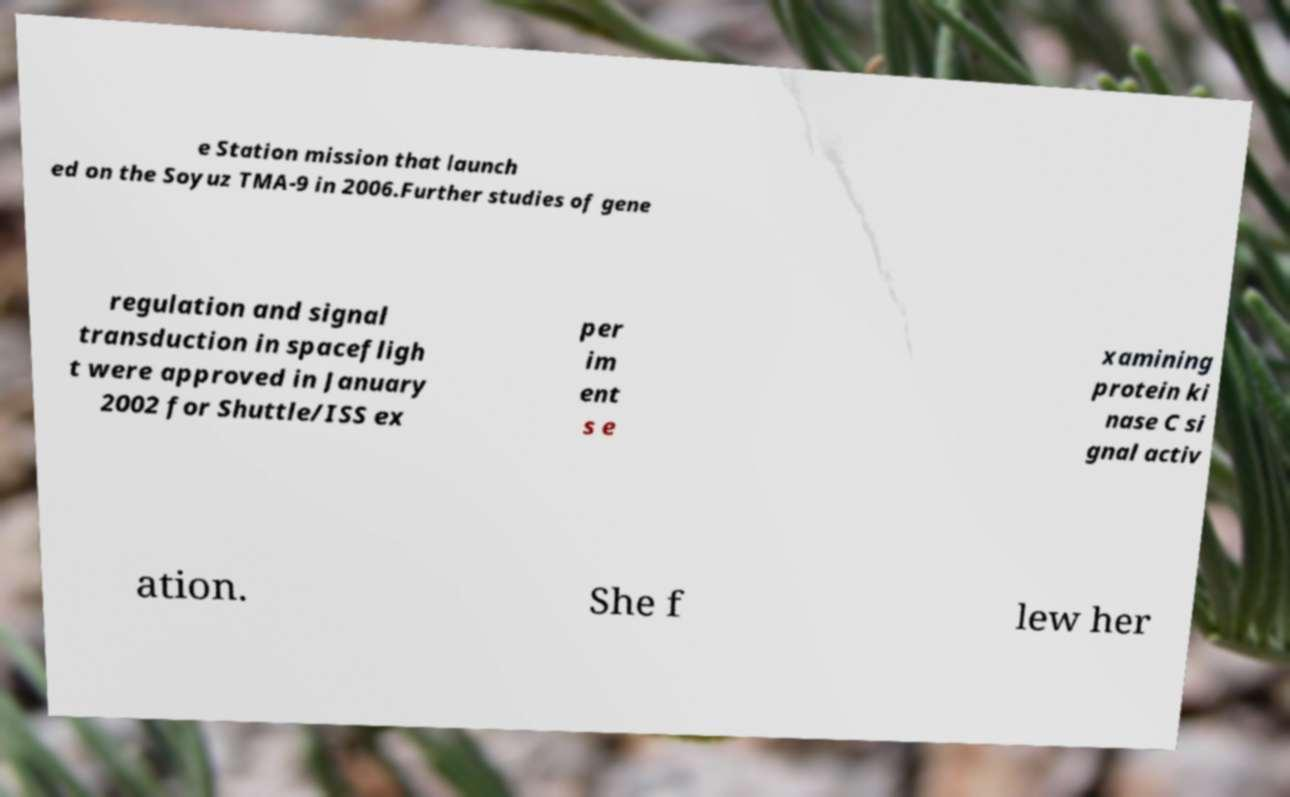Please read and relay the text visible in this image. What does it say? e Station mission that launch ed on the Soyuz TMA-9 in 2006.Further studies of gene regulation and signal transduction in spacefligh t were approved in January 2002 for Shuttle/ISS ex per im ent s e xamining protein ki nase C si gnal activ ation. She f lew her 